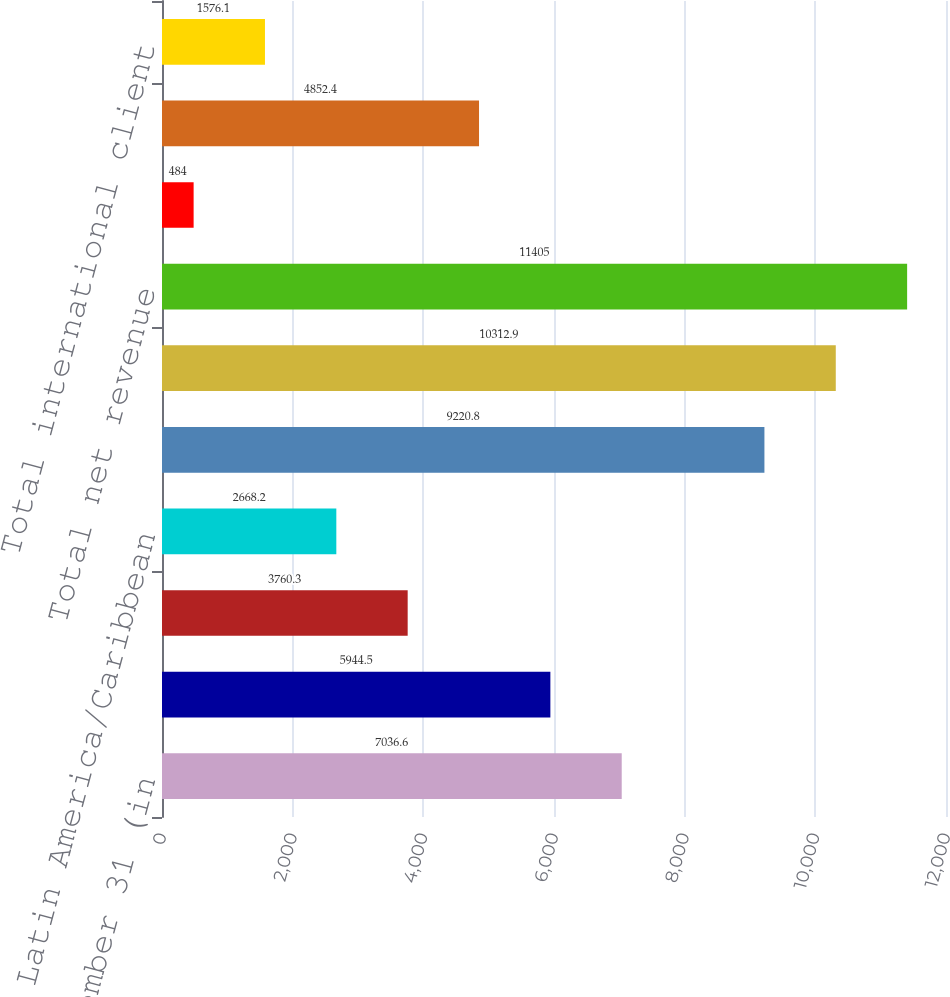Convert chart to OTSL. <chart><loc_0><loc_0><loc_500><loc_500><bar_chart><fcel>Year ended December 31 (in<fcel>Europe/Middle East/Africa<fcel>Asia/Pacific<fcel>Latin America/Caribbean<fcel>Total international net<fcel>North America<fcel>Total net revenue<fcel>Total international assets<fcel>Total assets under management<fcel>Total international client<nl><fcel>7036.6<fcel>5944.5<fcel>3760.3<fcel>2668.2<fcel>9220.8<fcel>10312.9<fcel>11405<fcel>484<fcel>4852.4<fcel>1576.1<nl></chart> 